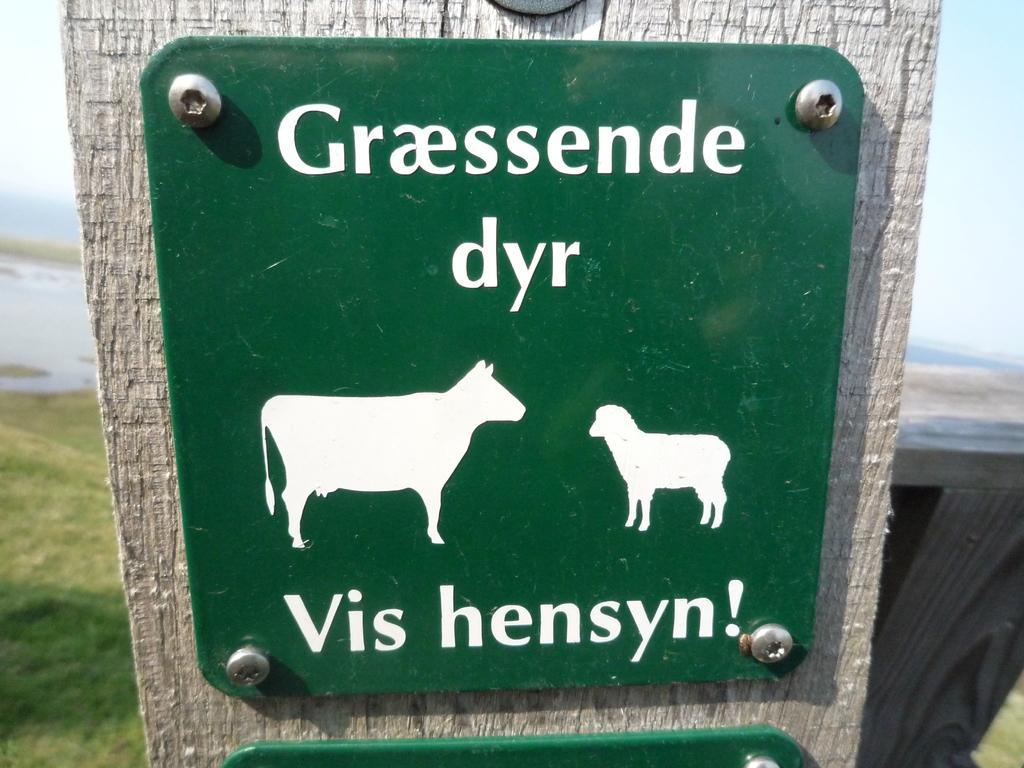Can you describe this image briefly? In the background we can see sky and grass. We can see green boards, there are depictions of animals and there is something written on the board. 